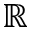Convert formula to latex. <formula><loc_0><loc_0><loc_500><loc_500>{ \mathbb { R } }</formula> 